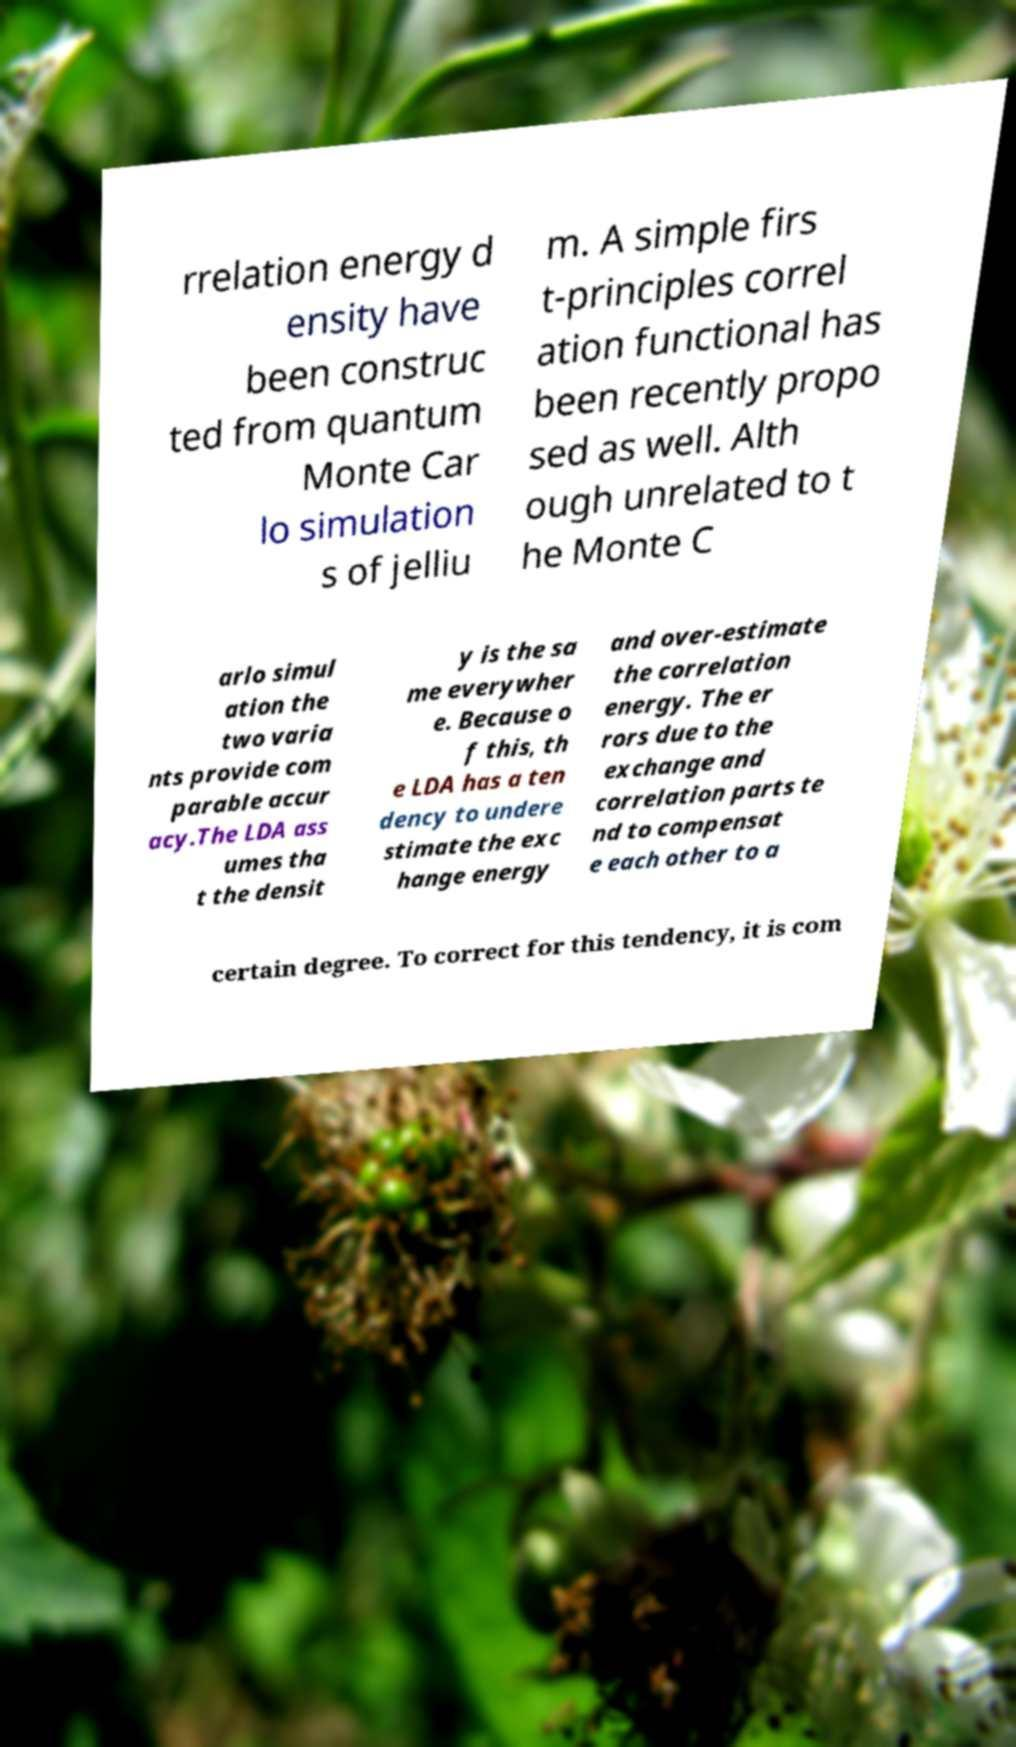Please identify and transcribe the text found in this image. rrelation energy d ensity have been construc ted from quantum Monte Car lo simulation s of jelliu m. A simple firs t-principles correl ation functional has been recently propo sed as well. Alth ough unrelated to t he Monte C arlo simul ation the two varia nts provide com parable accur acy.The LDA ass umes tha t the densit y is the sa me everywher e. Because o f this, th e LDA has a ten dency to undere stimate the exc hange energy and over-estimate the correlation energy. The er rors due to the exchange and correlation parts te nd to compensat e each other to a certain degree. To correct for this tendency, it is com 